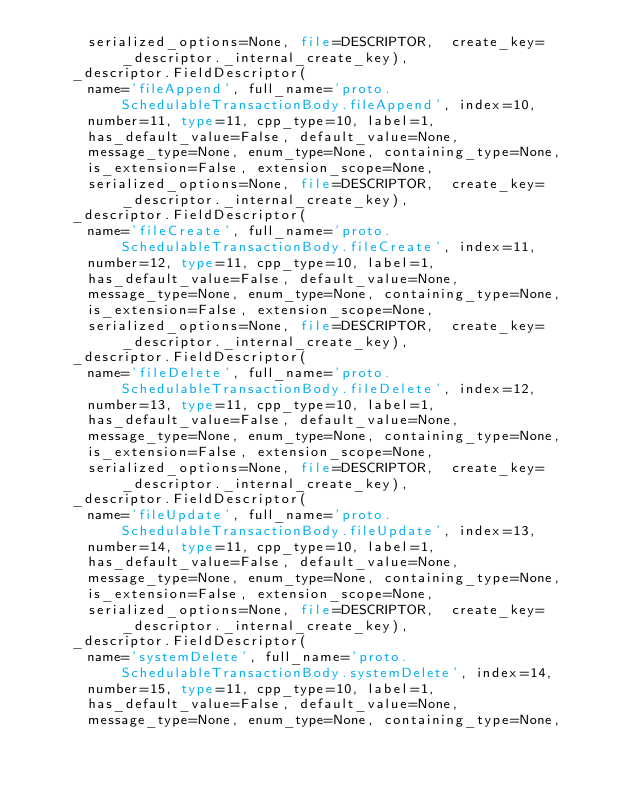Convert code to text. <code><loc_0><loc_0><loc_500><loc_500><_Python_>      serialized_options=None, file=DESCRIPTOR,  create_key=_descriptor._internal_create_key),
    _descriptor.FieldDescriptor(
      name='fileAppend', full_name='proto.SchedulableTransactionBody.fileAppend', index=10,
      number=11, type=11, cpp_type=10, label=1,
      has_default_value=False, default_value=None,
      message_type=None, enum_type=None, containing_type=None,
      is_extension=False, extension_scope=None,
      serialized_options=None, file=DESCRIPTOR,  create_key=_descriptor._internal_create_key),
    _descriptor.FieldDescriptor(
      name='fileCreate', full_name='proto.SchedulableTransactionBody.fileCreate', index=11,
      number=12, type=11, cpp_type=10, label=1,
      has_default_value=False, default_value=None,
      message_type=None, enum_type=None, containing_type=None,
      is_extension=False, extension_scope=None,
      serialized_options=None, file=DESCRIPTOR,  create_key=_descriptor._internal_create_key),
    _descriptor.FieldDescriptor(
      name='fileDelete', full_name='proto.SchedulableTransactionBody.fileDelete', index=12,
      number=13, type=11, cpp_type=10, label=1,
      has_default_value=False, default_value=None,
      message_type=None, enum_type=None, containing_type=None,
      is_extension=False, extension_scope=None,
      serialized_options=None, file=DESCRIPTOR,  create_key=_descriptor._internal_create_key),
    _descriptor.FieldDescriptor(
      name='fileUpdate', full_name='proto.SchedulableTransactionBody.fileUpdate', index=13,
      number=14, type=11, cpp_type=10, label=1,
      has_default_value=False, default_value=None,
      message_type=None, enum_type=None, containing_type=None,
      is_extension=False, extension_scope=None,
      serialized_options=None, file=DESCRIPTOR,  create_key=_descriptor._internal_create_key),
    _descriptor.FieldDescriptor(
      name='systemDelete', full_name='proto.SchedulableTransactionBody.systemDelete', index=14,
      number=15, type=11, cpp_type=10, label=1,
      has_default_value=False, default_value=None,
      message_type=None, enum_type=None, containing_type=None,</code> 